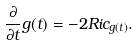<formula> <loc_0><loc_0><loc_500><loc_500>\frac { \partial } { \partial t } g ( t ) = - 2 R i c _ { g ( t ) } .</formula> 